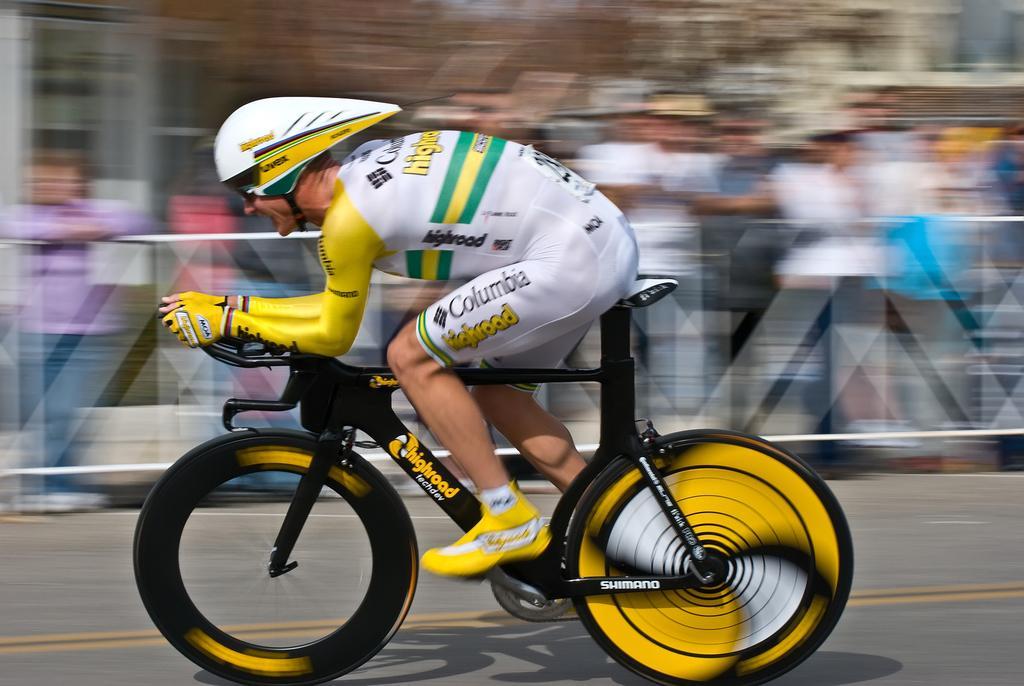Please provide a concise description of this image. In this image we can see a person riding a yellow and black bicycle. He is wearing a helmet and white and yellow dress. The background is blurred. 